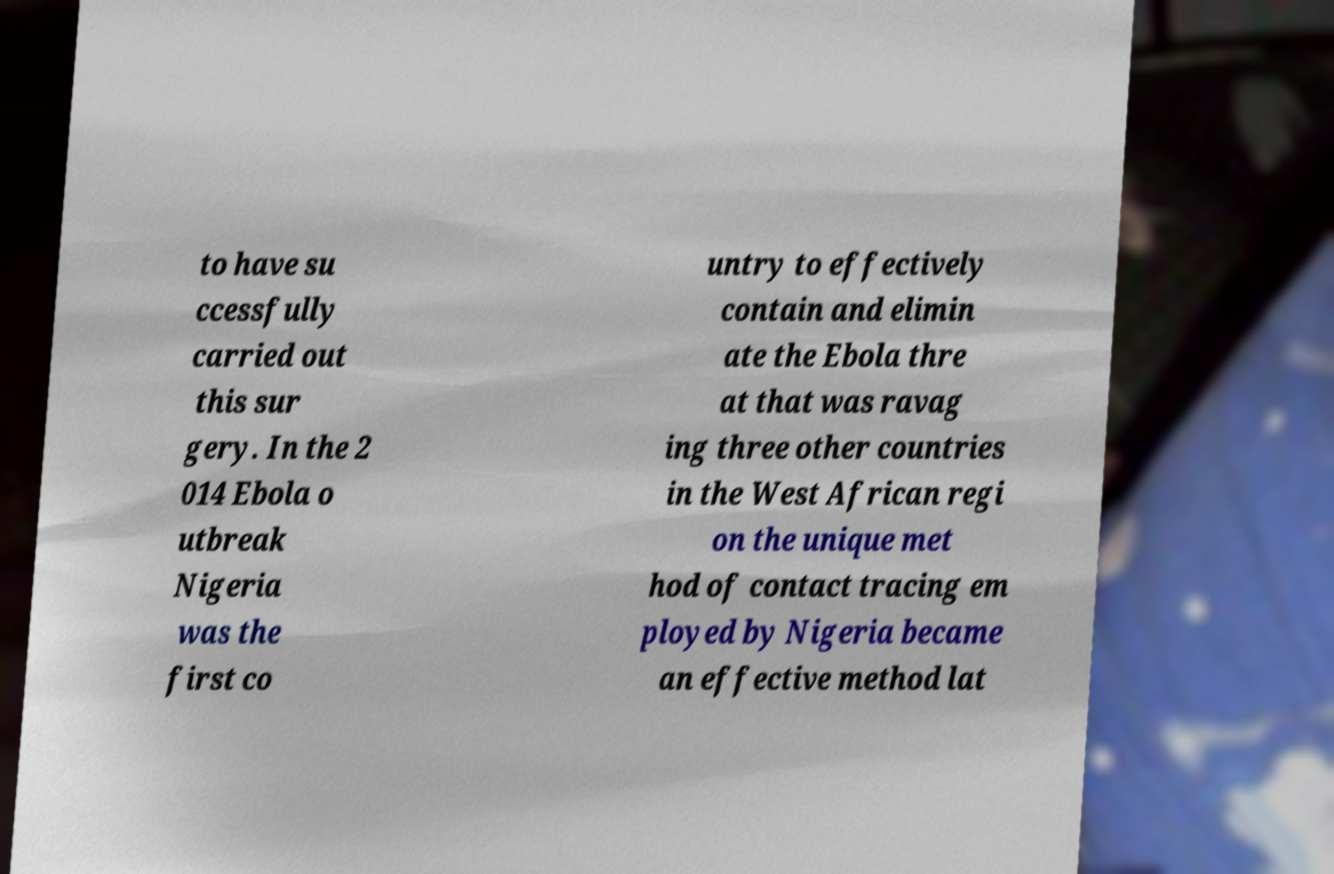For documentation purposes, I need the text within this image transcribed. Could you provide that? to have su ccessfully carried out this sur gery. In the 2 014 Ebola o utbreak Nigeria was the first co untry to effectively contain and elimin ate the Ebola thre at that was ravag ing three other countries in the West African regi on the unique met hod of contact tracing em ployed by Nigeria became an effective method lat 